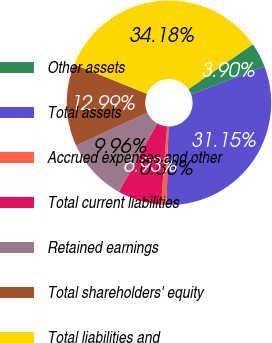Convert chart to OTSL. <chart><loc_0><loc_0><loc_500><loc_500><pie_chart><fcel>Other assets<fcel>Total assets<fcel>Accrued expenses and other<fcel>Total current liabilities<fcel>Retained earnings<fcel>Total shareholders' equity<fcel>Total liabilities and<nl><fcel>3.9%<fcel>31.15%<fcel>0.88%<fcel>6.93%<fcel>9.96%<fcel>12.99%<fcel>34.18%<nl></chart> 